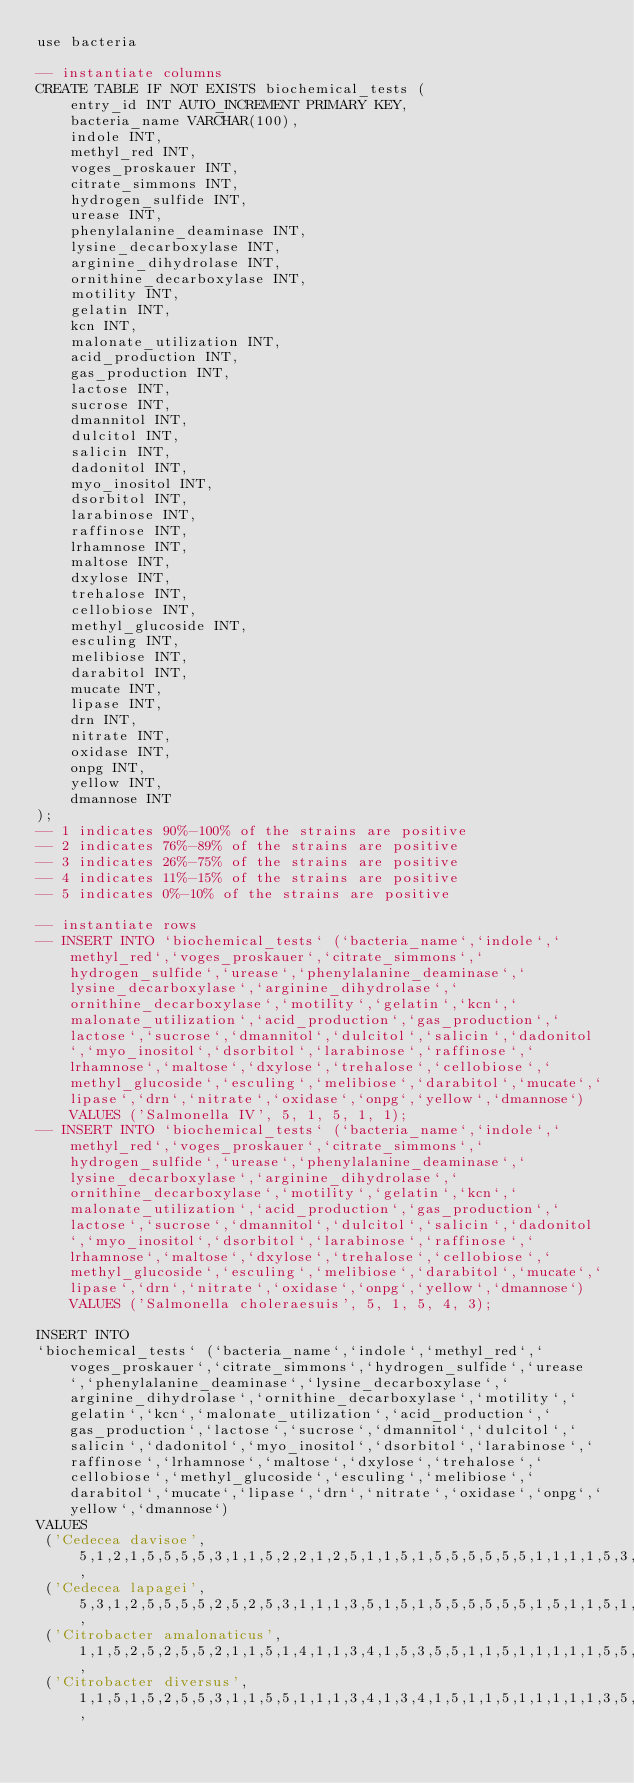Convert code to text. <code><loc_0><loc_0><loc_500><loc_500><_SQL_>use bacteria

-- instantiate columns
CREATE TABLE IF NOT EXISTS biochemical_tests (
    entry_id INT AUTO_INCREMENT PRIMARY KEY,
    bacteria_name VARCHAR(100),
    indole INT,
    methyl_red INT,
    voges_proskauer INT,
    citrate_simmons INT,
    hydrogen_sulfide INT,
    urease INT,
    phenylalanine_deaminase INT,
    lysine_decarboxylase INT,
    arginine_dihydrolase INT,
    ornithine_decarboxylase INT,
    motility INT,
    gelatin INT,
    kcn INT,
    malonate_utilization INT,
    acid_production INT,
    gas_production INT,
    lactose INT,
    sucrose INT,
    dmannitol INT,
    dulcitol INT,
    salicin INT,
    dadonitol INT,
    myo_inositol INT,
    dsorbitol INT,
    larabinose INT,
    raffinose INT,
    lrhamnose INT,
    maltose INT,
    dxylose INT,
    trehalose INT,
    cellobiose INT,
    methyl_glucoside INT,
    esculing INT,
    melibiose INT,
    darabitol INT,
    mucate INT,
    lipase INT,
    drn INT,
    nitrate INT,
    oxidase INT,
    onpg INT,
    yellow INT,
    dmannose INT
);
-- 1 indicates 90%-100% of the strains are positive
-- 2 indicates 76%-89% of the strains are positive
-- 3 indicates 26%-75% of the strains are positive
-- 4 indicates 11%-15% of the strains are positive
-- 5 indicates 0%-10% of the strains are positive

-- instantiate rows
-- INSERT INTO `biochemical_tests` (`bacteria_name`,`indole`,`methyl_red`,`voges_proskauer`,`citrate_simmons`,`hydrogen_sulfide`,`urease`,`phenylalanine_deaminase`,`lysine_decarboxylase`,`arginine_dihydrolase`,`ornithine_decarboxylase`,`motility`,`gelatin`,`kcn`,`malonate_utilization`,`acid_production`,`gas_production`,`lactose`,`sucrose`,`dmannitol`,`dulcitol`,`salicin`,`dadonitol`,`myo_inositol`,`dsorbitol`,`larabinose`,`raffinose`,`lrhamnose`,`maltose`,`dxylose`,`trehalose`,`cellobiose`,`methyl_glucoside`,`esculing`,`melibiose`,`darabitol`,`mucate`,`lipase`,`drn`,`nitrate`,`oxidase`,`onpg`,`yellow`,`dmannose`) VALUES ('Salmonella IV', 5, 1, 5, 1, 1);
-- INSERT INTO `biochemical_tests` (`bacteria_name`,`indole`,`methyl_red`,`voges_proskauer`,`citrate_simmons`,`hydrogen_sulfide`,`urease`,`phenylalanine_deaminase`,`lysine_decarboxylase`,`arginine_dihydrolase`,`ornithine_decarboxylase`,`motility`,`gelatin`,`kcn`,`malonate_utilization`,`acid_production`,`gas_production`,`lactose`,`sucrose`,`dmannitol`,`dulcitol`,`salicin`,`dadonitol`,`myo_inositol`,`dsorbitol`,`larabinose`,`raffinose`,`lrhamnose`,`maltose`,`dxylose`,`trehalose`,`cellobiose`,`methyl_glucoside`,`esculing`,`melibiose`,`darabitol`,`mucate`,`lipase`,`drn`,`nitrate`,`oxidase`,`onpg`,`yellow`,`dmannose`) VALUES ('Salmonella choleraesuis', 5, 1, 5, 4, 3);

INSERT INTO 
`biochemical_tests` (`bacteria_name`,`indole`,`methyl_red`,`voges_proskauer`,`citrate_simmons`,`hydrogen_sulfide`,`urease`,`phenylalanine_deaminase`,`lysine_decarboxylase`,`arginine_dihydrolase`,`ornithine_decarboxylase`,`motility`,`gelatin`,`kcn`,`malonate_utilization`,`acid_production`,`gas_production`,`lactose`,`sucrose`,`dmannitol`,`dulcitol`,`salicin`,`dadonitol`,`myo_inositol`,`dsorbitol`,`larabinose`,`raffinose`,`lrhamnose`,`maltose`,`dxylose`,`trehalose`,`cellobiose`,`methyl_glucoside`,`esculing`,`melibiose`,`darabitol`,`mucate`,`lipase`,`drn`,`nitrate`,`oxidase`,`onpg`,`yellow`,`dmannose`) 
VALUES 
 ('Cedecea davisoe', 5,1,2,1,5,5,5,5,3,1,1,5,2,2,1,2,5,1,1,5,1,5,5,5,5,5,5,1,1,1,1,5,3,5,1,5,2,5,1,5,2,5,1),
 ('Cedecea lapagei', 5,3,1,2,5,5,5,5,2,5,2,5,3,1,1,1,3,5,1,5,1,5,5,5,5,5,5,1,5,1,1,5,1,5,1,5,1,5,1,5,1,5,1),
 ('Citrobacter amalonaticus', 1,1,5,2,5,2,5,5,2,1,1,5,1,4,1,1,3,4,1,5,3,5,5,1,1,5,1,1,1,1,1,5,5,4,5,1,5,5,1,5,1,5,1),
 ('Citrobacter diversus', 1,1,5,1,5,2,5,5,3,1,1,5,5,1,1,1,3,4,1,3,4,1,5,1,1,5,1,1,1,1,1,3,5,5,1,1,5,5,1,5,1,5,1),</code> 